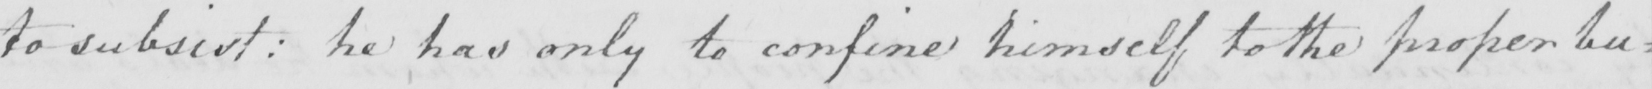Please provide the text content of this handwritten line. to subsist :  he has only to confine himself to the proper bu= 